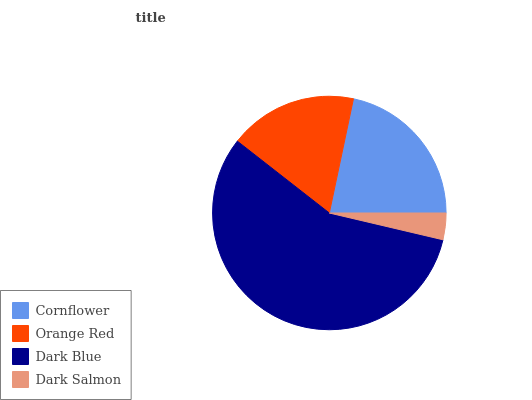Is Dark Salmon the minimum?
Answer yes or no. Yes. Is Dark Blue the maximum?
Answer yes or no. Yes. Is Orange Red the minimum?
Answer yes or no. No. Is Orange Red the maximum?
Answer yes or no. No. Is Cornflower greater than Orange Red?
Answer yes or no. Yes. Is Orange Red less than Cornflower?
Answer yes or no. Yes. Is Orange Red greater than Cornflower?
Answer yes or no. No. Is Cornflower less than Orange Red?
Answer yes or no. No. Is Cornflower the high median?
Answer yes or no. Yes. Is Orange Red the low median?
Answer yes or no. Yes. Is Dark Salmon the high median?
Answer yes or no. No. Is Dark Salmon the low median?
Answer yes or no. No. 